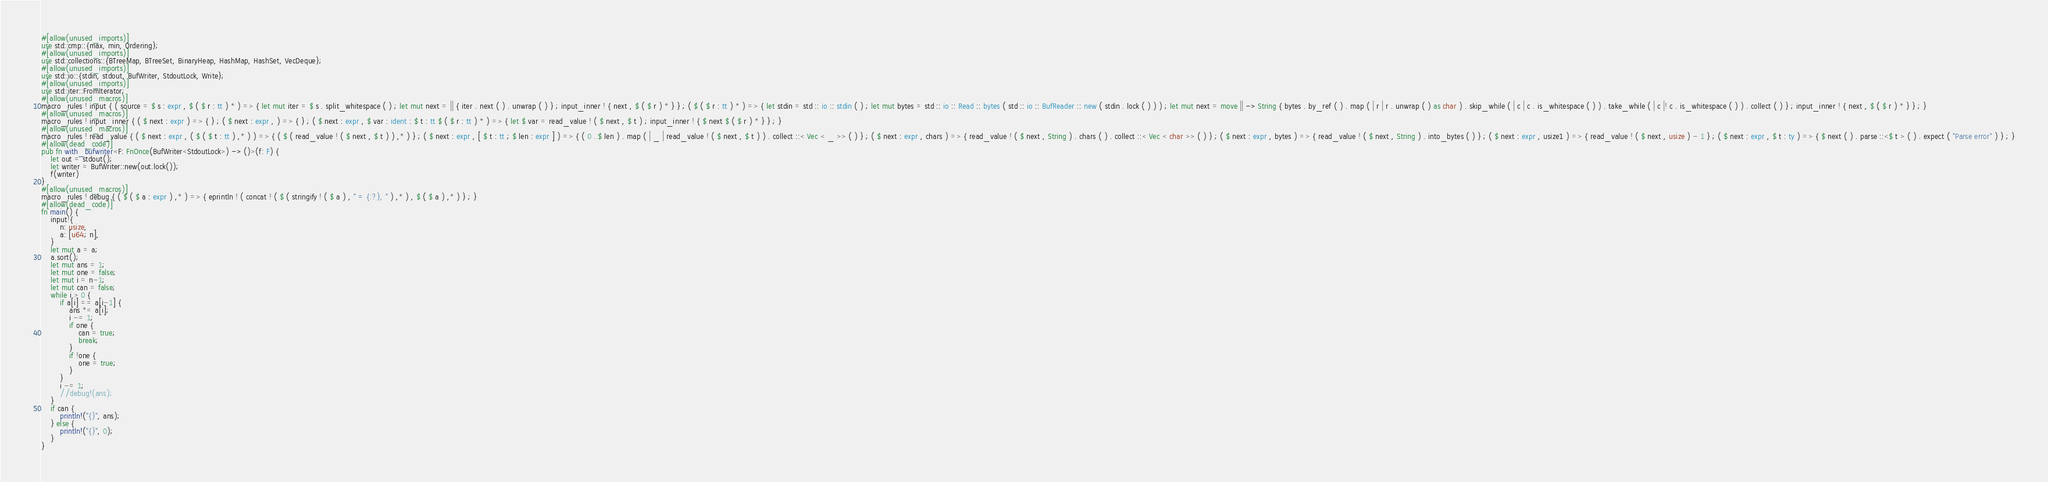Convert code to text. <code><loc_0><loc_0><loc_500><loc_500><_Rust_>#[allow(unused_imports)]
use std::cmp::{max, min, Ordering};
#[allow(unused_imports)]
use std::collections::{BTreeMap, BTreeSet, BinaryHeap, HashMap, HashSet, VecDeque};
#[allow(unused_imports)]
use std::io::{stdin, stdout, BufWriter, StdoutLock, Write};
#[allow(unused_imports)]
use std::iter::FromIterator;
#[allow(unused_macros)]
macro_rules ! input { ( source = $ s : expr , $ ( $ r : tt ) * ) => { let mut iter = $ s . split_whitespace ( ) ; let mut next = || { iter . next ( ) . unwrap ( ) } ; input_inner ! { next , $ ( $ r ) * } } ; ( $ ( $ r : tt ) * ) => { let stdin = std :: io :: stdin ( ) ; let mut bytes = std :: io :: Read :: bytes ( std :: io :: BufReader :: new ( stdin . lock ( ) ) ) ; let mut next = move || -> String { bytes . by_ref ( ) . map ( | r | r . unwrap ( ) as char ) . skip_while ( | c | c . is_whitespace ( ) ) . take_while ( | c |! c . is_whitespace ( ) ) . collect ( ) } ; input_inner ! { next , $ ( $ r ) * } } ; }
#[allow(unused_macros)]
macro_rules ! input_inner { ( $ next : expr ) => { } ; ( $ next : expr , ) => { } ; ( $ next : expr , $ var : ident : $ t : tt $ ( $ r : tt ) * ) => { let $ var = read_value ! ( $ next , $ t ) ; input_inner ! { $ next $ ( $ r ) * } } ; }
#[allow(unused_macros)]
macro_rules ! read_value { ( $ next : expr , ( $ ( $ t : tt ) ,* ) ) => { ( $ ( read_value ! ( $ next , $ t ) ) ,* ) } ; ( $ next : expr , [ $ t : tt ; $ len : expr ] ) => { ( 0 ..$ len ) . map ( | _ | read_value ! ( $ next , $ t ) ) . collect ::< Vec < _ >> ( ) } ; ( $ next : expr , chars ) => { read_value ! ( $ next , String ) . chars ( ) . collect ::< Vec < char >> ( ) } ; ( $ next : expr , bytes ) => { read_value ! ( $ next , String ) . into_bytes ( ) } ; ( $ next : expr , usize1 ) => { read_value ! ( $ next , usize ) - 1 } ; ( $ next : expr , $ t : ty ) => { $ next ( ) . parse ::<$ t > ( ) . expect ( "Parse error" ) } ; }
#[allow(dead_code)]
pub fn with_bufwriter<F: FnOnce(BufWriter<StdoutLock>) -> ()>(f: F) {
    let out = stdout();
    let writer = BufWriter::new(out.lock());
    f(writer)
}
#[allow(unused_macros)]
macro_rules ! debug { ( $ ( $ a : expr ) ,* ) => { eprintln ! ( concat ! ( $ ( stringify ! ( $ a ) , " = {:?}, " ) ,* ) , $ ( $ a ) ,* ) } ; }
#[allow(dead_code)]
fn main() {
    input!{
        n: usize,
        a: [u64; n],
    }
    let mut a = a;
    a.sort();
    let mut ans = 1;
    let mut one = false;
    let mut i = n-1;
    let mut can = false;
    while i > 0 {
        if a[i] == a[i-1] {
            ans *= a[i];
            i -= 1;
            if one {
                can = true;
                break;
            }
            if !one {
                one = true;
            }
        }
        i -= 1;
        //debug!(ans);
    }
    if can {
        println!("{}", ans);
    } else {
        println!("{}", 0);
    }
}</code> 